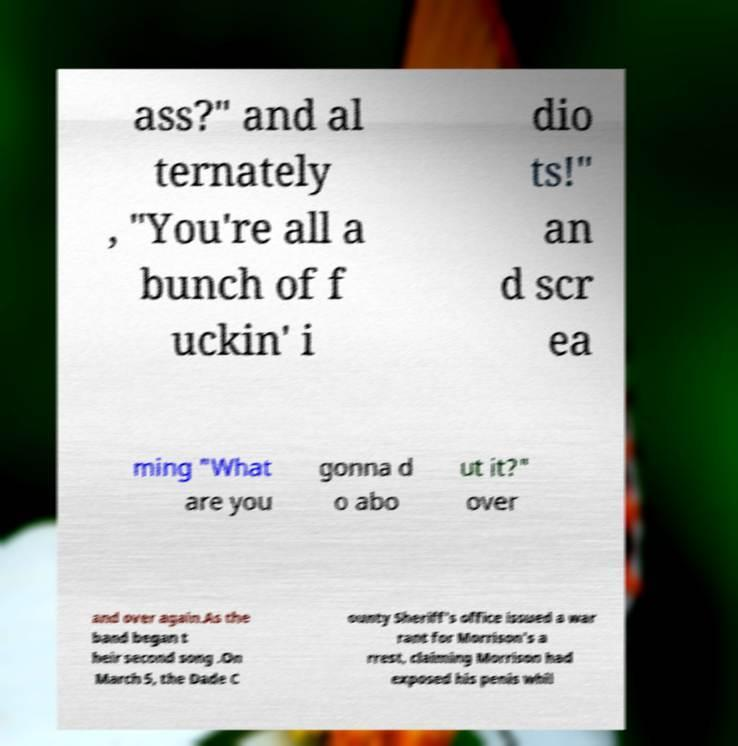What messages or text are displayed in this image? I need them in a readable, typed format. ass?" and al ternately , "You're all a bunch of f uckin' i dio ts!" an d scr ea ming "What are you gonna d o abo ut it?" over and over again.As the band began t heir second song .On March 5, the Dade C ounty Sheriff's office issued a war rant for Morrison's a rrest, claiming Morrison had exposed his penis whil 